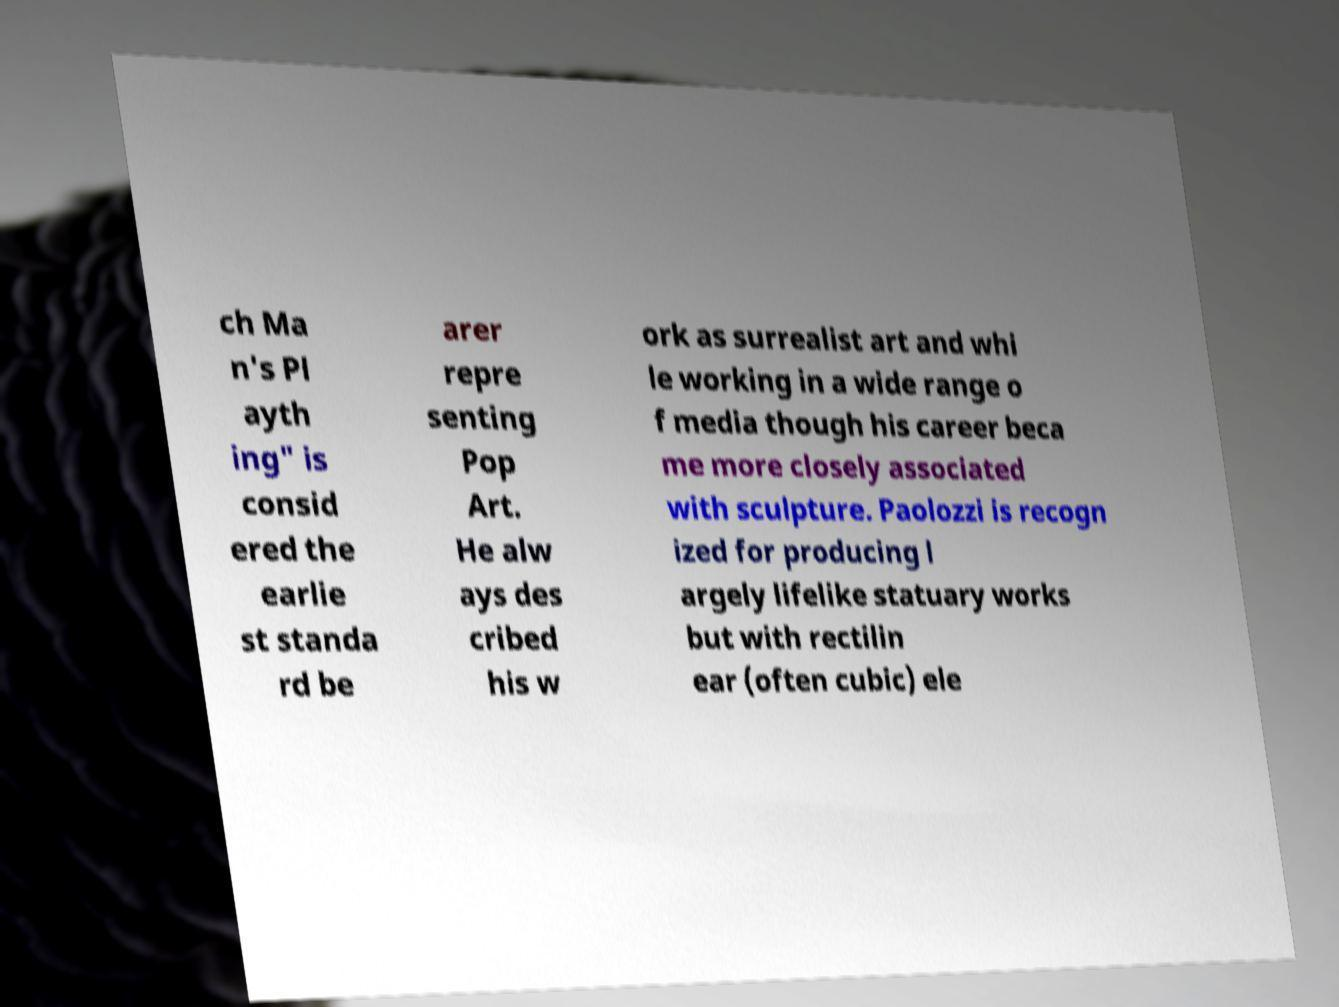Please identify and transcribe the text found in this image. ch Ma n's Pl ayth ing" is consid ered the earlie st standa rd be arer repre senting Pop Art. He alw ays des cribed his w ork as surrealist art and whi le working in a wide range o f media though his career beca me more closely associated with sculpture. Paolozzi is recogn ized for producing l argely lifelike statuary works but with rectilin ear (often cubic) ele 